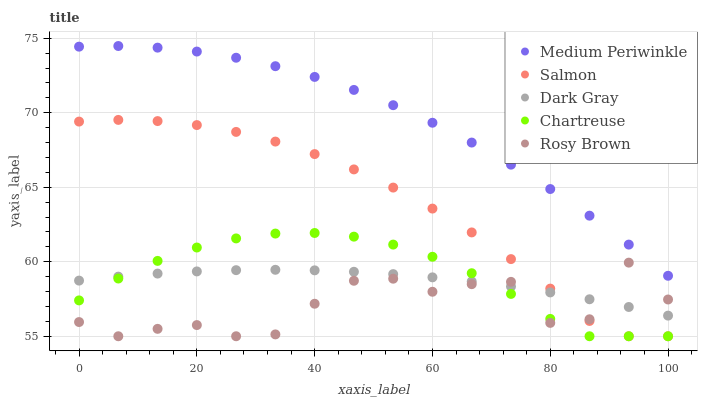Does Rosy Brown have the minimum area under the curve?
Answer yes or no. Yes. Does Medium Periwinkle have the maximum area under the curve?
Answer yes or no. Yes. Does Salmon have the minimum area under the curve?
Answer yes or no. No. Does Salmon have the maximum area under the curve?
Answer yes or no. No. Is Dark Gray the smoothest?
Answer yes or no. Yes. Is Rosy Brown the roughest?
Answer yes or no. Yes. Is Salmon the smoothest?
Answer yes or no. No. Is Salmon the roughest?
Answer yes or no. No. Does Salmon have the lowest value?
Answer yes or no. Yes. Does Medium Periwinkle have the lowest value?
Answer yes or no. No. Does Medium Periwinkle have the highest value?
Answer yes or no. Yes. Does Salmon have the highest value?
Answer yes or no. No. Is Chartreuse less than Medium Periwinkle?
Answer yes or no. Yes. Is Medium Periwinkle greater than Chartreuse?
Answer yes or no. Yes. Does Chartreuse intersect Salmon?
Answer yes or no. Yes. Is Chartreuse less than Salmon?
Answer yes or no. No. Is Chartreuse greater than Salmon?
Answer yes or no. No. Does Chartreuse intersect Medium Periwinkle?
Answer yes or no. No. 